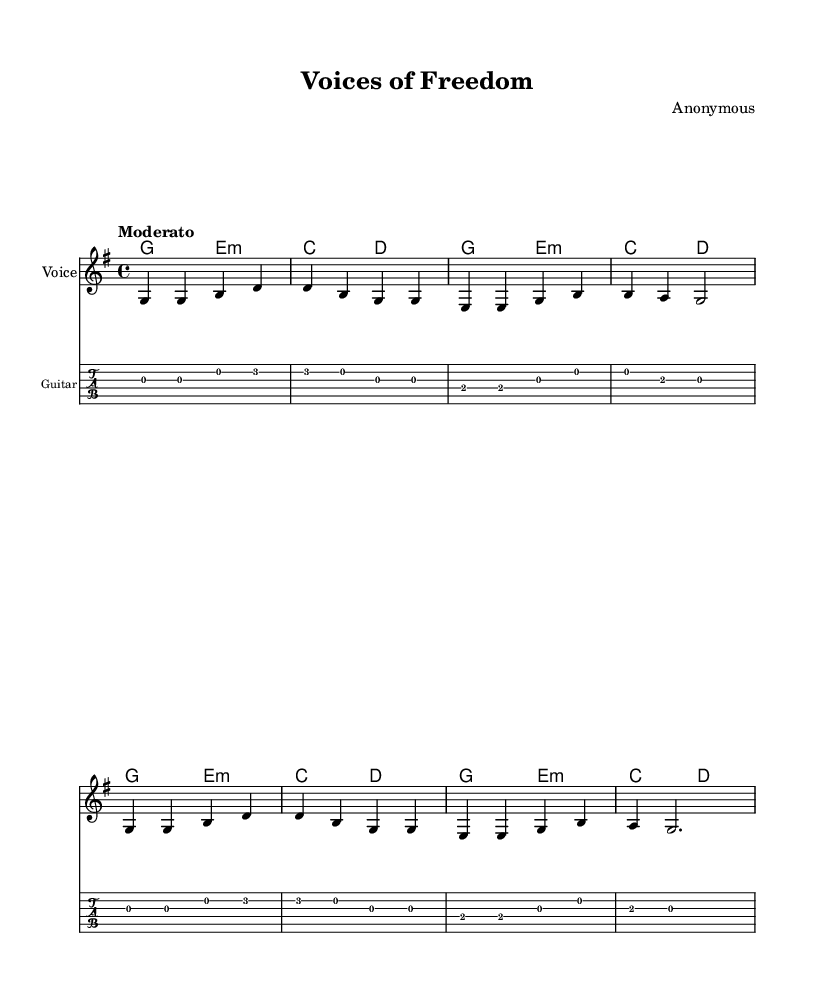What is the key signature of this music? The key signature shows one sharp (F#), indicating G major.
Answer: G major What is the time signature of this music? The time signature is 4/4, which means there are four beats in each measure.
Answer: 4/4 What is the tempo marking for this piece? The tempo marking indicates a moderate speed, generally interpreted as walking pace.
Answer: Moderato How many measures are present in the melody? Counting the measures in the melody, there are eight measures shown.
Answer: Eight What is the first note of the melody? Looking at the first measure, the first note is G, which is written on the second line of the staff.
Answer: G How many different chords are used throughout the piece? The chords listed are G major, E minor, C major, and D major, totalling four different chords.
Answer: Four What is the last note of the melody? The last note of the melody is G, found in the final measure before the double bar line.
Answer: G 